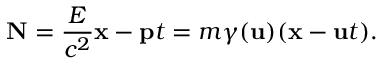Convert formula to latex. <formula><loc_0><loc_0><loc_500><loc_500>N = { \frac { E } { c ^ { 2 } } } x - p t = m \gamma ( u ) ( x - u t ) .</formula> 